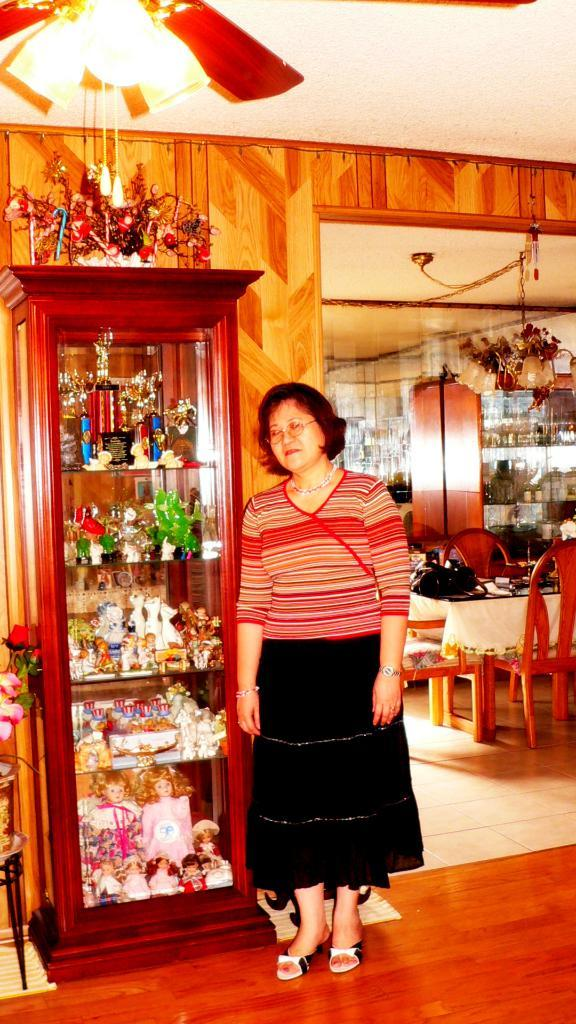Who is present in the image? There is a woman in the image. What is the woman doing in the image? The woman is standing. What accessory is the woman wearing in the image? The woman is wearing glasses (specs) in the image. What type of furniture can be seen in the background of the image? There are chairs and a table in the background of the image. What personal item is visible in the background of the image? There is a bag in the background of the image. Can you describe any other objects or items in the background of the image? There are additional unspecified items in the background of the image. What type of basin is the woman using to wash her hands in the image? There is no basin present in the image, and the woman is not washing her hands. How does the society depicted in the image influence the woman's actions? The image does not depict a society, and therefore it cannot be determined how society might influence the woman's actions. 